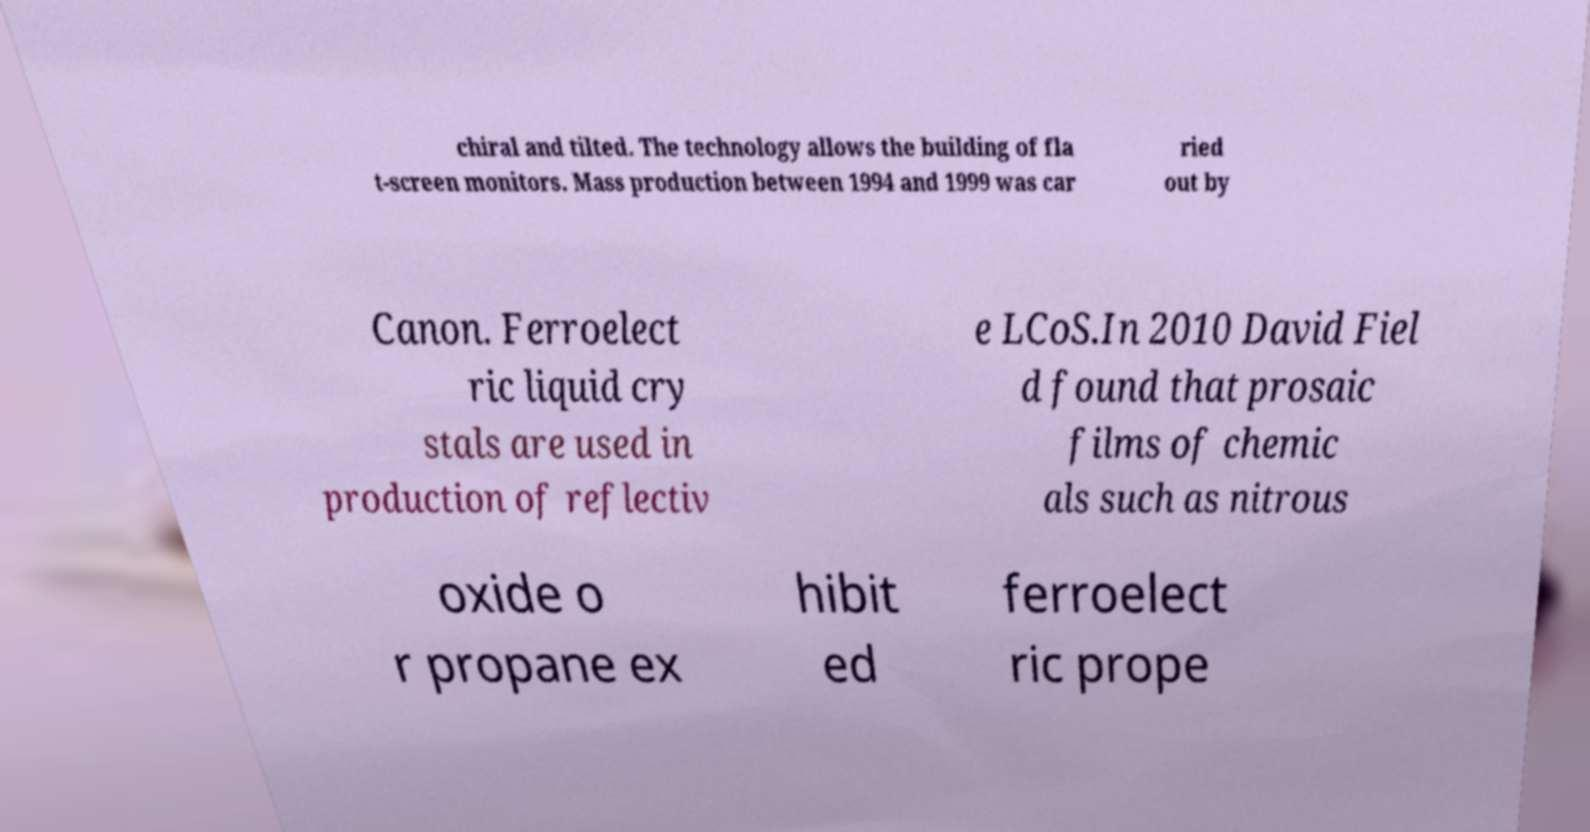Could you extract and type out the text from this image? chiral and tilted. The technology allows the building of fla t-screen monitors. Mass production between 1994 and 1999 was car ried out by Canon. Ferroelect ric liquid cry stals are used in production of reflectiv e LCoS.In 2010 David Fiel d found that prosaic films of chemic als such as nitrous oxide o r propane ex hibit ed ferroelect ric prope 